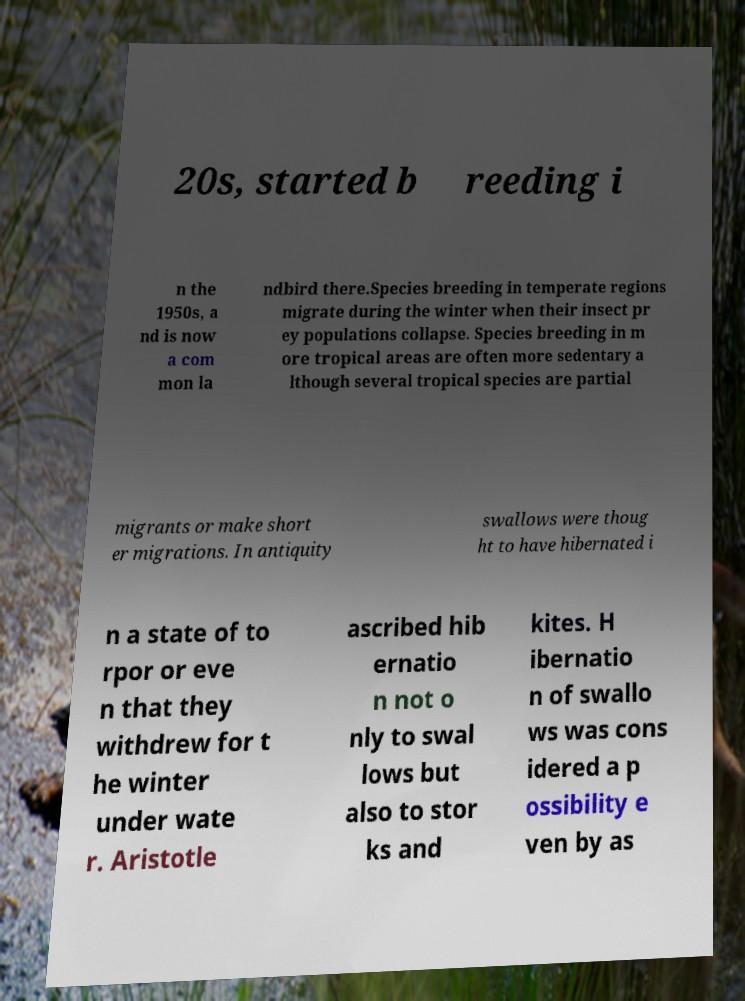For documentation purposes, I need the text within this image transcribed. Could you provide that? 20s, started b reeding i n the 1950s, a nd is now a com mon la ndbird there.Species breeding in temperate regions migrate during the winter when their insect pr ey populations collapse. Species breeding in m ore tropical areas are often more sedentary a lthough several tropical species are partial migrants or make short er migrations. In antiquity swallows were thoug ht to have hibernated i n a state of to rpor or eve n that they withdrew for t he winter under wate r. Aristotle ascribed hib ernatio n not o nly to swal lows but also to stor ks and kites. H ibernatio n of swallo ws was cons idered a p ossibility e ven by as 